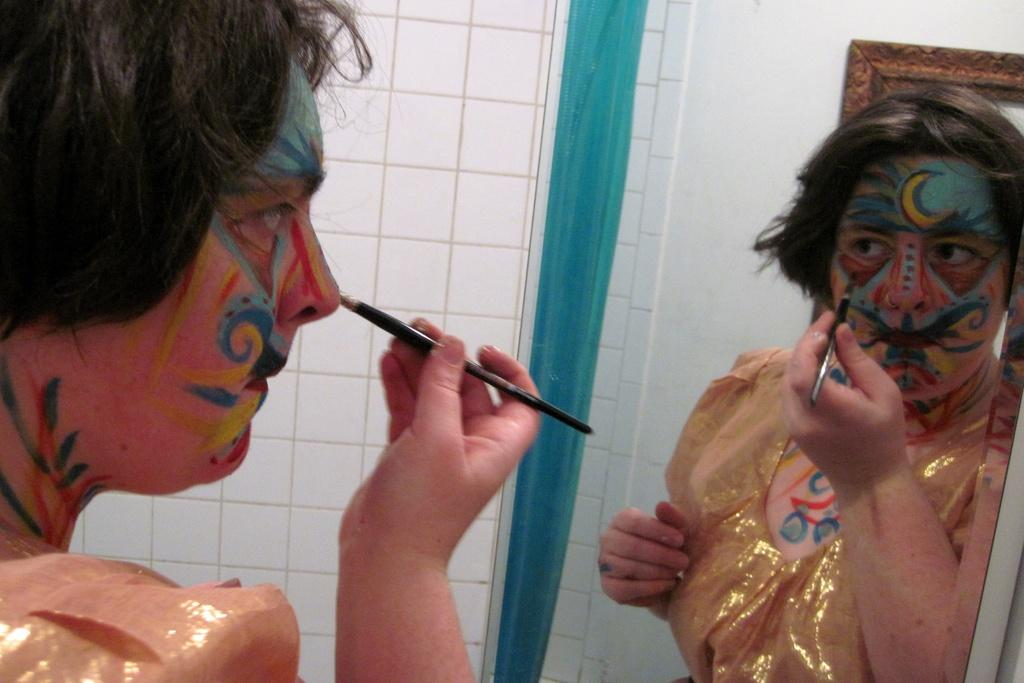What is the main subject of the image? There is a person in the image. What is the person holding in the image? The person is holding a pencil. Can you describe the person's appearance in the image? The person has makeup on their face. What object can be seen on the wall in the image? There is a mirror on the wall in the image. How does the person apply the brake in the image? There is no reference to a vehicle or a brake in the image, so it is not possible to answer that question. 